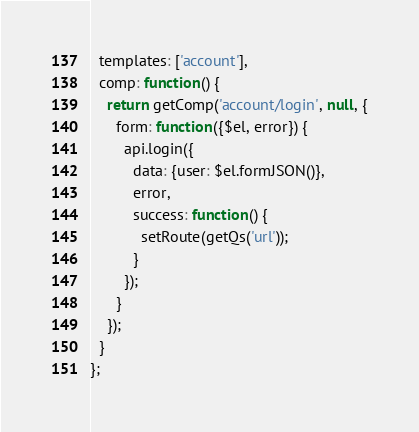Convert code to text. <code><loc_0><loc_0><loc_500><loc_500><_JavaScript_>  templates: ['account'],
  comp: function() {
    return getComp('account/login', null, {
      form: function({$el, error}) {
        api.login({
          data: {user: $el.formJSON()},
          error,
          success: function() {
            setRoute(getQs('url'));
          }
        });
      }
    });
  }
};
</code> 